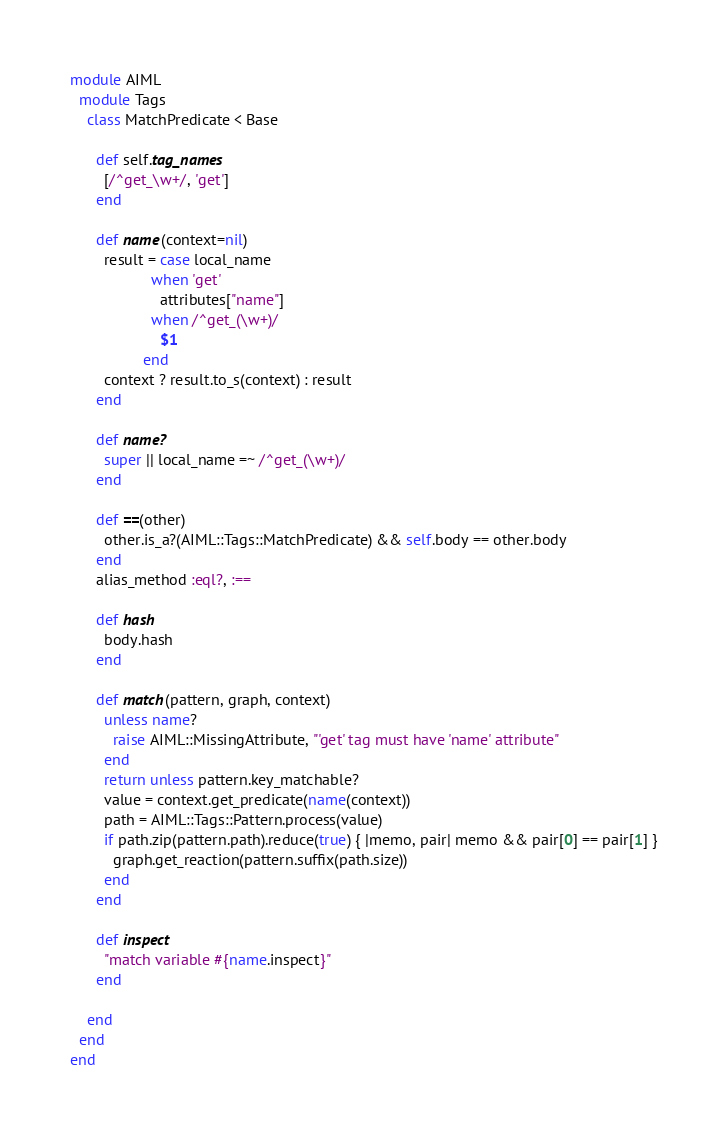<code> <loc_0><loc_0><loc_500><loc_500><_Ruby_>module AIML
  module Tags
    class MatchPredicate < Base

      def self.tag_names
        [/^get_\w+/, 'get']
      end

      def name(context=nil)
        result = case local_name
                   when 'get'
                     attributes["name"]
                   when /^get_(\w+)/
                     $1
                 end
        context ? result.to_s(context) : result
      end

      def name?
        super || local_name =~ /^get_(\w+)/
      end

      def ==(other)
        other.is_a?(AIML::Tags::MatchPredicate) && self.body == other.body
      end
      alias_method :eql?, :==

      def hash
        body.hash
      end

      def match(pattern, graph, context)
        unless name?
          raise AIML::MissingAttribute, "'get' tag must have 'name' attribute"
        end
        return unless pattern.key_matchable?
        value = context.get_predicate(name(context))
        path = AIML::Tags::Pattern.process(value)
        if path.zip(pattern.path).reduce(true) { |memo, pair| memo && pair[0] == pair[1] }
          graph.get_reaction(pattern.suffix(path.size))
        end
      end

      def inspect
        "match variable #{name.inspect}"
      end

    end
  end
end
</code> 